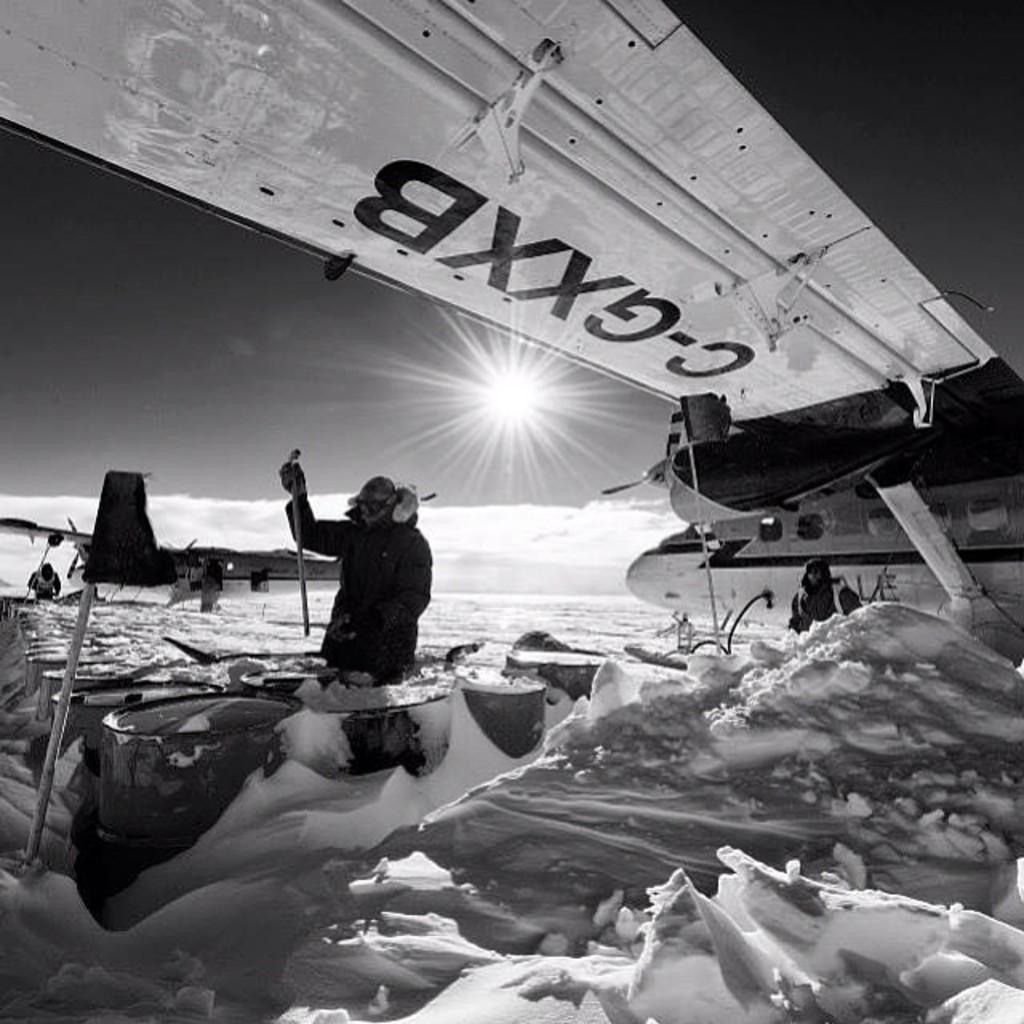What number can be seen on the box?
Offer a terse response. Unanswerable. 